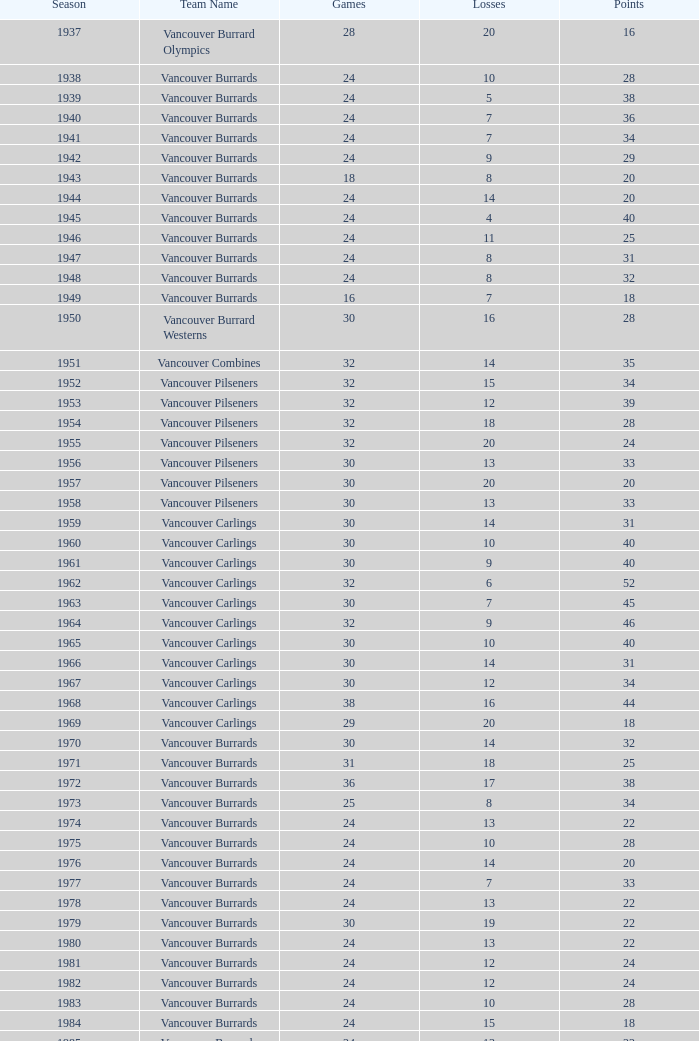What is the total number of points for the 1963 season when over 30 games are played? None. 